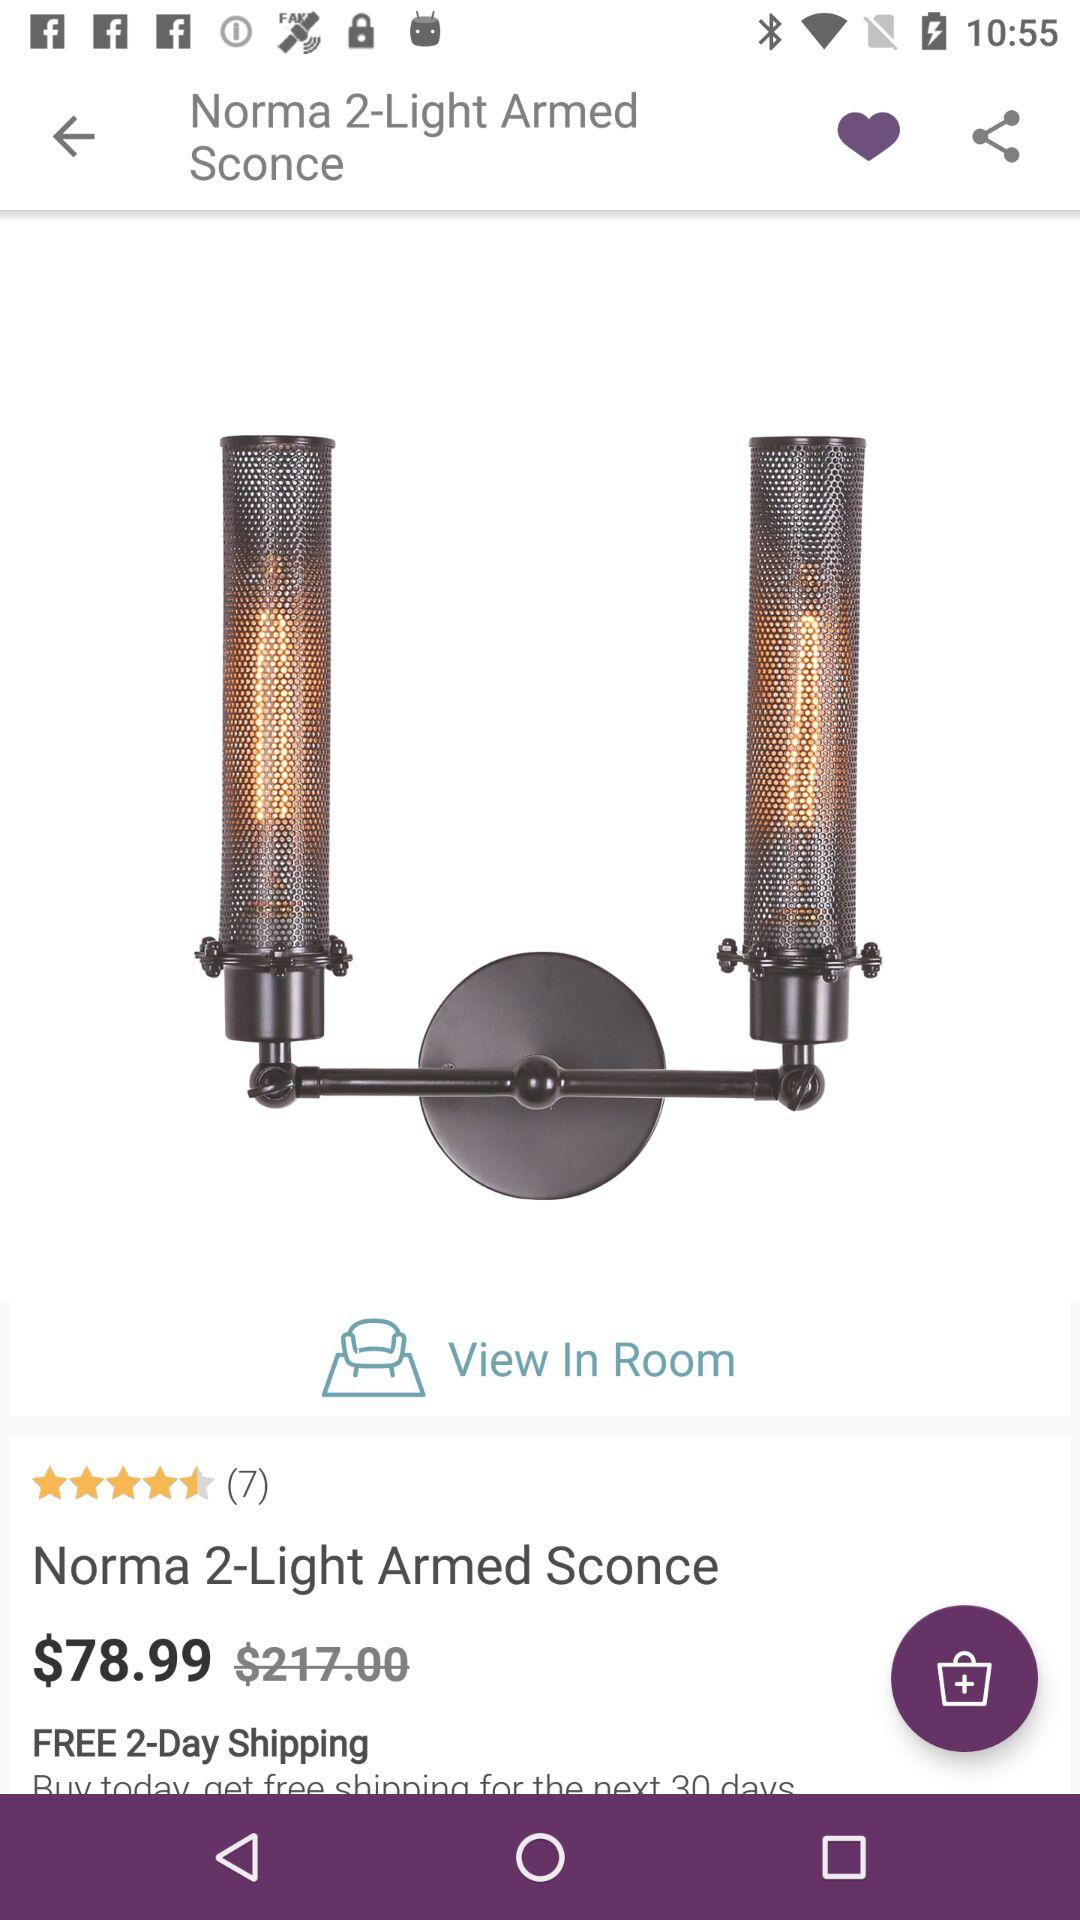How much does "Norma 2-Light Armed Sconce" cost?
Answer the question using a single word or phrase. It costs $78.99. 